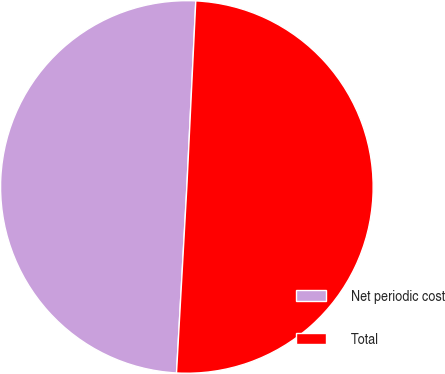<chart> <loc_0><loc_0><loc_500><loc_500><pie_chart><fcel>Net periodic cost<fcel>Total<nl><fcel>49.88%<fcel>50.12%<nl></chart> 